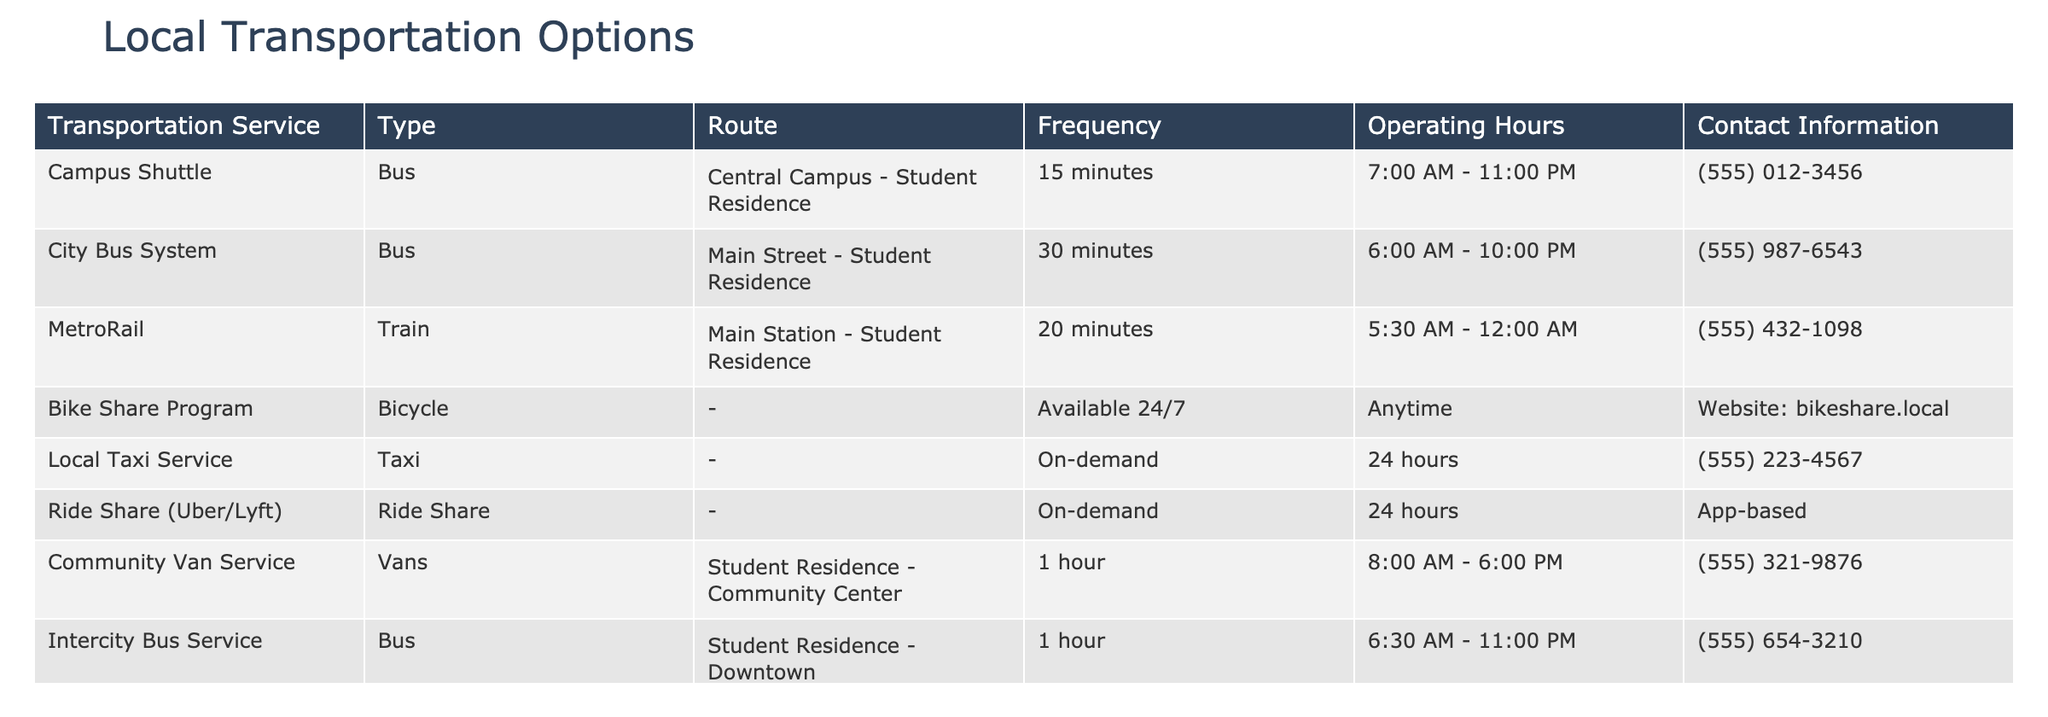What is the operating hour for the Campus Shuttle? The table shows that the operating hours for the Campus Shuttle are from 7:00 AM to 11:00 PM.
Answer: 7:00 AM - 11:00 PM How often does the City Bus system run? According to the table, the City Bus system has a frequency of every 30 minutes.
Answer: 30 minutes Is the Bike Share Program available at all times? The table indicates that the Bike Share Program is available 24/7, meaning it operates at all times.
Answer: Yes Which service operates most frequently and what is its frequency? From the table, the Campus Shuttle operates every 15 minutes, which is the highest frequency compared to other services listed.
Answer: Campus Shuttle, 15 minutes What’s the difference in operating hours between the MetroRail and the Community Van Service? The MetroRail operates from 5:30 AM to 12:00 AM (18.5 hours) while the Community Van Service operates from 8:00 AM to 6:00 PM (10 hours). The difference is 8.5 hours.
Answer: 8.5 hours How many transportation options operate 24 hours? By reviewing the table, we find that there are two options that operate 24 hours: Local Taxi Service and Ride Share.
Answer: 2 Which transportation option has the longest operating hours and what are they? The MetroRail has the longest operating hours from 5:30 AM to 12:00 AM, giving it a total of 18.5 hours of operation.
Answer: MetroRail, 5:30 AM - 12:00 AM Are taxi services available on-demand? The table states that the Local Taxi Service and Ride Share options operate on-demand, indicating that they are indeed available as needed.
Answer: Yes What is the total number of public transport options listed in the table? Counting the entries in the transportation service column, there are a total of eight options listed.
Answer: 8 